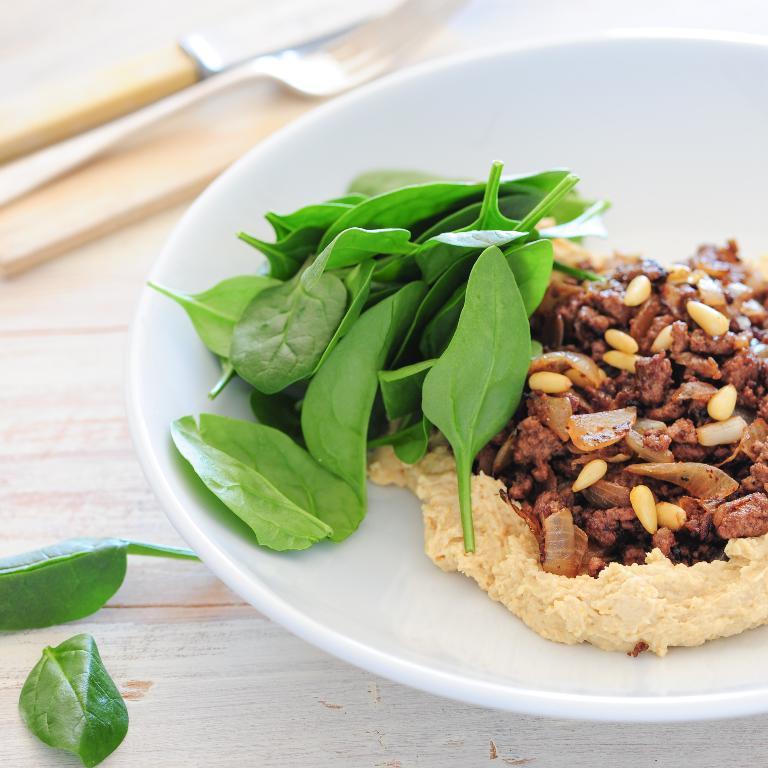Can you describe this image briefly? In this image we can see some food and leafy vegetables in a plate which is placed on the table. We can also see a knife, fork and some leaves beside it. 